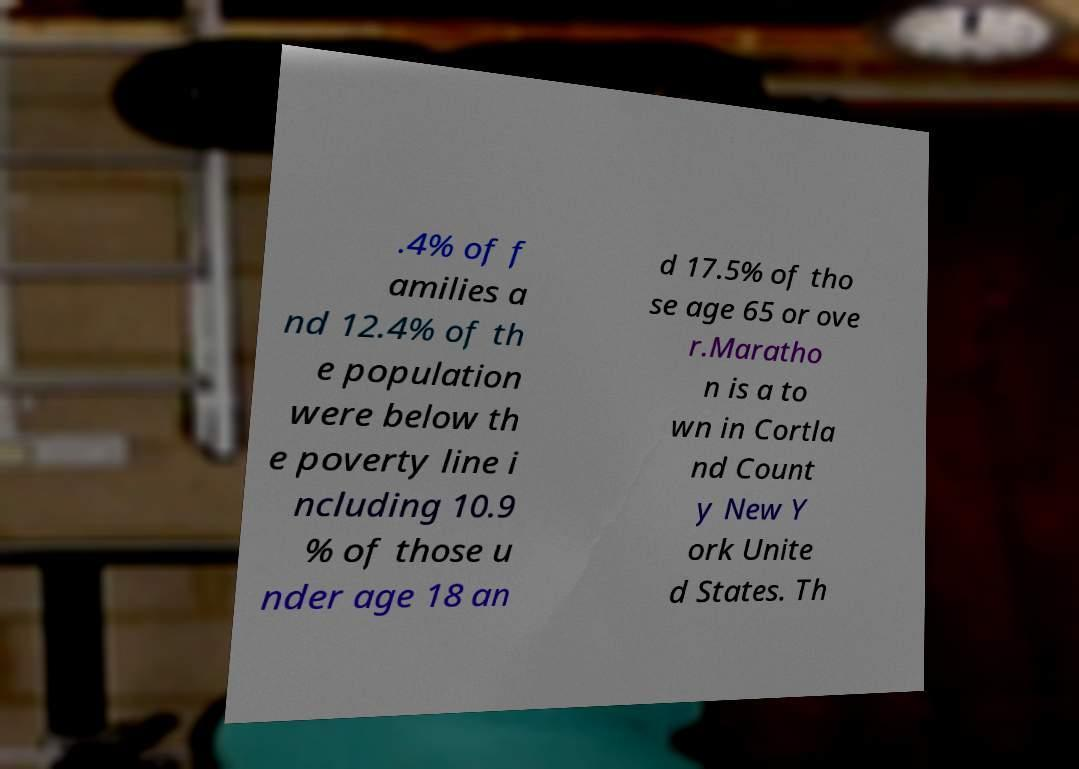What messages or text are displayed in this image? I need them in a readable, typed format. .4% of f amilies a nd 12.4% of th e population were below th e poverty line i ncluding 10.9 % of those u nder age 18 an d 17.5% of tho se age 65 or ove r.Maratho n is a to wn in Cortla nd Count y New Y ork Unite d States. Th 